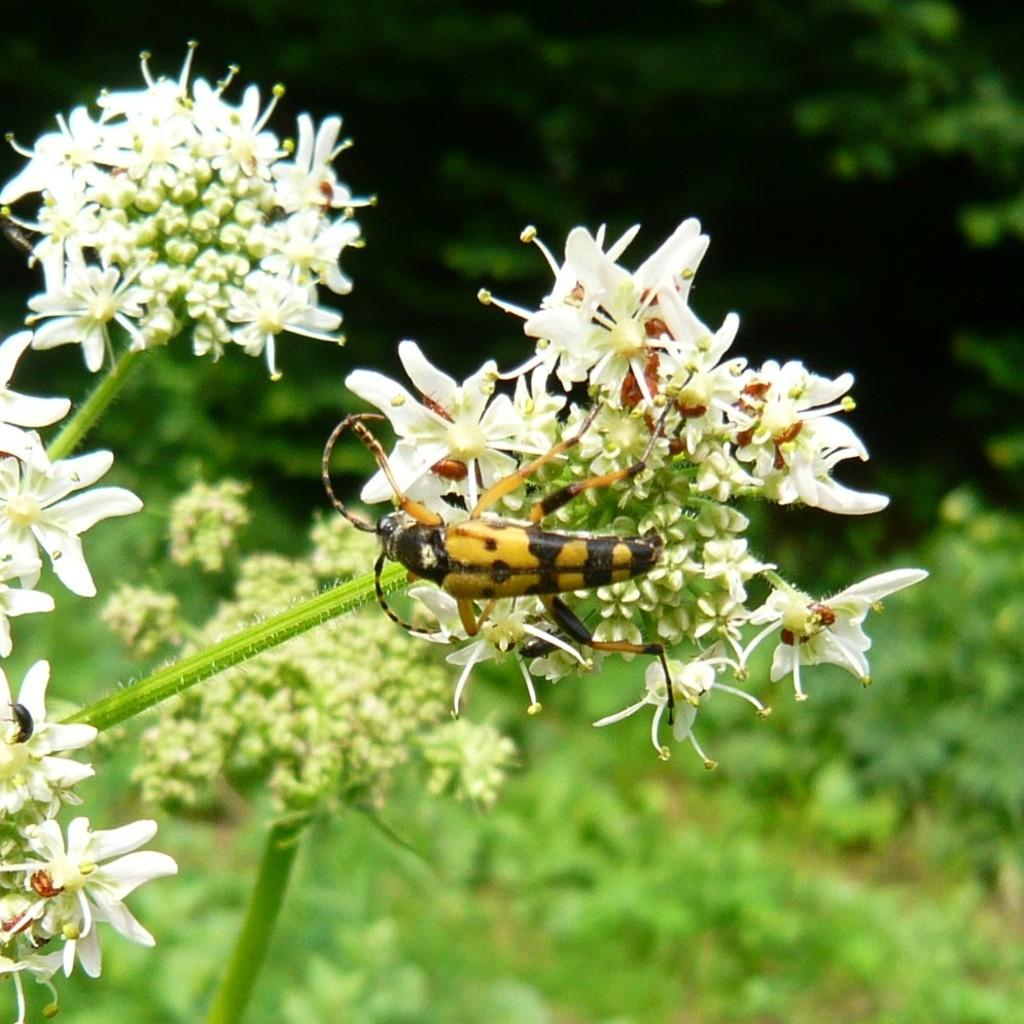What type of vegetation can be seen on the back side of the image? There is greenery visible on the back side of the image. Can you describe the flower in the image? There is a white color flower with a stem in the image. Is there any living organism present on the flower? Yes, a bug is standing on the flower. How many rabbits are present at the birthday party in the image? There is no mention of a birthday party or rabbits in the image; it features a flower with a bug on it and greenery in the background. 